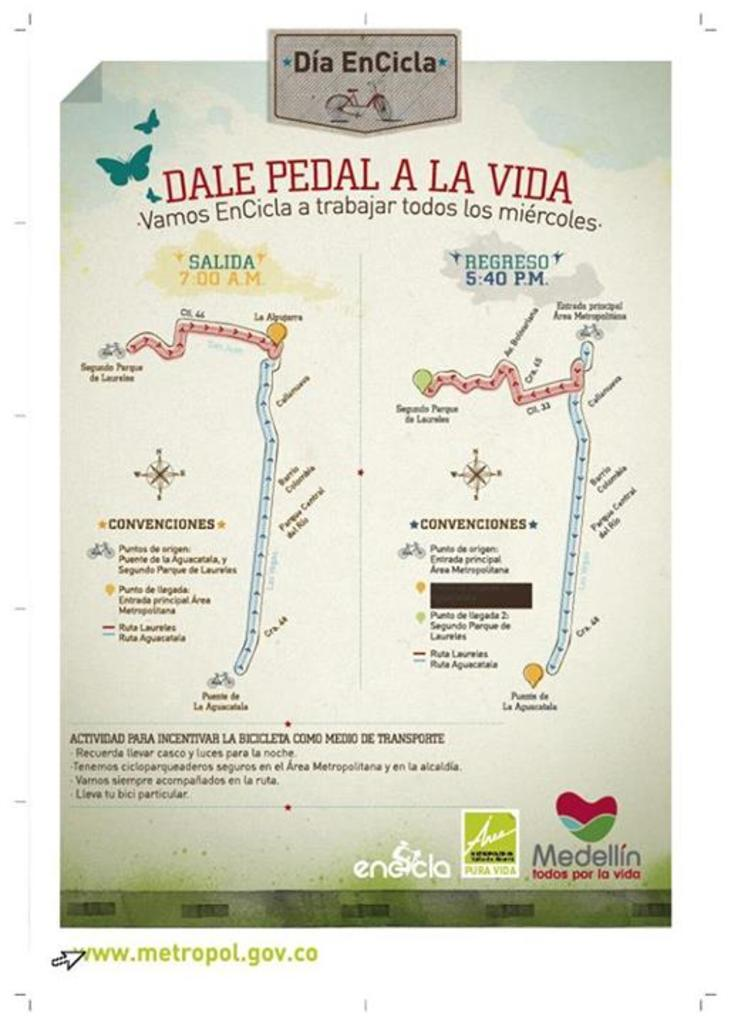Provide a one-sentence caption for the provided image. A sheet of paper with Dia EnVicla at the top. 